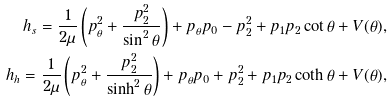<formula> <loc_0><loc_0><loc_500><loc_500>h _ { s } = \frac { 1 } { 2 \mu } \left ( p _ { \theta } ^ { 2 } + \frac { p _ { 2 } ^ { 2 } } { \sin ^ { 2 } \theta } \right ) + p _ { \theta } p _ { 0 } - p _ { 2 } ^ { 2 } + p _ { 1 } p _ { 2 } \cot \theta + V ( \theta ) , \\ h _ { h } = \frac { 1 } { 2 \mu } \left ( p _ { \theta } ^ { 2 } + \frac { p _ { 2 } ^ { 2 } } { \sinh ^ { 2 } \theta } \right ) + p _ { \theta } p _ { 0 } + p _ { 2 } ^ { 2 } + p _ { 1 } p _ { 2 } \coth \theta + V ( \theta ) ,</formula> 